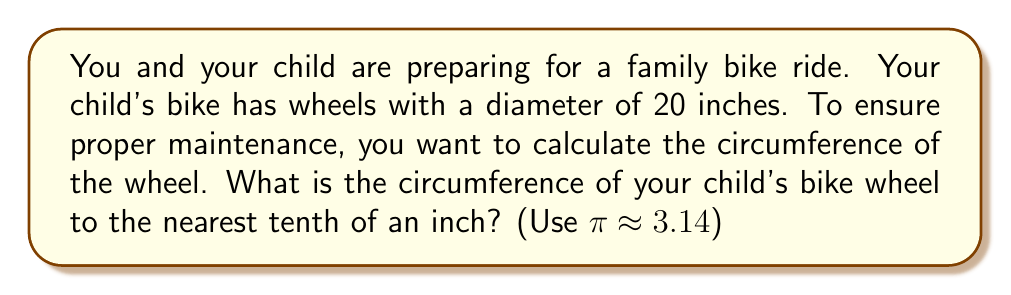Can you solve this math problem? Let's approach this step-by-step:

1) The formula for the circumference of a circle is:
   
   $$C = \pi d$$
   
   where $C$ is the circumference, $\pi$ is pi, and $d$ is the diameter.

2) We're given that the diameter is 20 inches and we should use $\pi \approx 3.14$.

3) Let's substitute these values into our formula:

   $$C = 3.14 \times 20$$

4) Now we can calculate:

   $$C = 62.8\text{ inches}$$

5) Rounding to the nearest tenth of an inch:

   $$C \approx 62.8\text{ inches}$$

[asy]
size(200);
draw(circle((0,0),1), black+1);
draw((0,0)--(1,0), red+1, Arrow);
label("$r$", (0.5,0), S, red);
label("Diameter = 20 inches", (0,-1.2), black);
[/asy]

This diagram illustrates a bike wheel. The red line represents the radius, and the diameter is twice this length.
Answer: The circumference of your child's bike wheel is approximately 62.8 inches. 